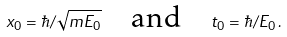Convert formula to latex. <formula><loc_0><loc_0><loc_500><loc_500>x _ { 0 } = \hbar { / } \sqrt { m E _ { 0 } } \quad \text {and} \quad t _ { 0 } = \hbar { / } E _ { 0 } \, .</formula> 